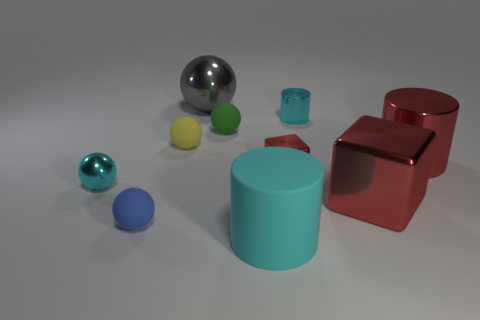What number of other things are the same material as the yellow ball?
Offer a very short reply. 3. Do the tiny cyan thing that is right of the big ball and the red object that is to the left of the tiny cyan metallic cylinder have the same shape?
Your answer should be compact. No. There is a cube to the right of the cyan cylinder that is behind the cyan metal thing that is left of the large cyan matte object; what color is it?
Your answer should be very brief. Red. What number of other things are the same color as the big matte thing?
Your response must be concise. 2. Are there fewer purple matte spheres than shiny cylinders?
Make the answer very short. Yes. There is a cylinder that is behind the small blue matte ball and on the left side of the large red cylinder; what is its color?
Ensure brevity in your answer.  Cyan. What material is the small green object that is the same shape as the blue object?
Make the answer very short. Rubber. Are there more matte balls than balls?
Ensure brevity in your answer.  No. There is a cylinder that is both in front of the small green sphere and behind the tiny red shiny block; what is its size?
Offer a terse response. Large. What is the shape of the cyan matte thing?
Offer a very short reply. Cylinder. 